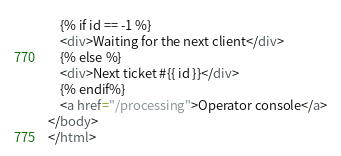Convert code to text. <code><loc_0><loc_0><loc_500><loc_500><_HTML_>    {% if id == -1 %}
    <div>Waiting for the next client</div>
    {% else %}
    <div>Next ticket #{{ id }}</div>
    {% endif%}
    <a href="/processing">Operator console</a>
</body>
</html></code> 